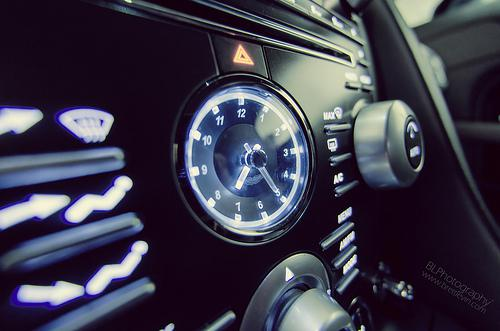Question: what time does the console reflect?
Choices:
A. 5:33.
B. 7:25.
C. 2:10.
D. 1:00.
Answer with the letter. Answer: B Question: how many white arrows facing the right are on the console?
Choices:
A. Four.
B. Three.
C. Five.
D. Six.
Answer with the letter. Answer: B Question: what is in the foreground?
Choices:
A. Car console.
B. Pigs.
C. Poppies.
D. Apples.
Answer with the letter. Answer: A Question: how many knows are on the console?
Choices:
A. Two.
B. Three.
C. Four.
D. Five.
Answer with the letter. Answer: A 